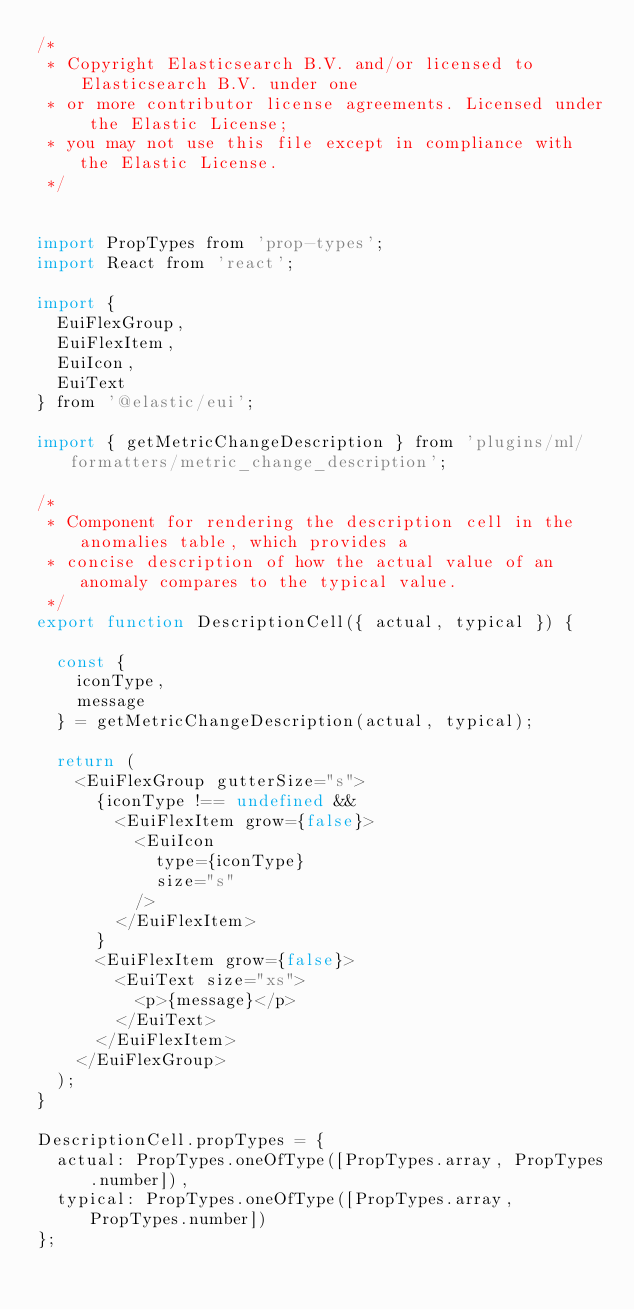<code> <loc_0><loc_0><loc_500><loc_500><_JavaScript_>/*
 * Copyright Elasticsearch B.V. and/or licensed to Elasticsearch B.V. under one
 * or more contributor license agreements. Licensed under the Elastic License;
 * you may not use this file except in compliance with the Elastic License.
 */


import PropTypes from 'prop-types';
import React from 'react';

import {
  EuiFlexGroup,
  EuiFlexItem,
  EuiIcon,
  EuiText
} from '@elastic/eui';

import { getMetricChangeDescription } from 'plugins/ml/formatters/metric_change_description';

/*
 * Component for rendering the description cell in the anomalies table, which provides a
 * concise description of how the actual value of an anomaly compares to the typical value.
 */
export function DescriptionCell({ actual, typical }) {

  const {
    iconType,
    message
  } = getMetricChangeDescription(actual, typical);

  return (
    <EuiFlexGroup gutterSize="s">
      {iconType !== undefined &&
        <EuiFlexItem grow={false}>
          <EuiIcon
            type={iconType}
            size="s"
          />
        </EuiFlexItem>
      }
      <EuiFlexItem grow={false}>
        <EuiText size="xs">
          <p>{message}</p>
        </EuiText>
      </EuiFlexItem>
    </EuiFlexGroup>
  );
}

DescriptionCell.propTypes = {
  actual: PropTypes.oneOfType([PropTypes.array, PropTypes.number]),
  typical: PropTypes.oneOfType([PropTypes.array, PropTypes.number])
};
</code> 